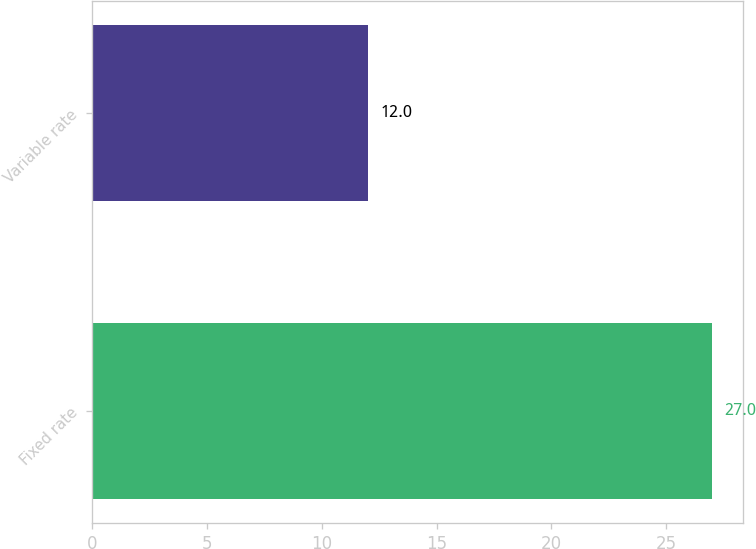<chart> <loc_0><loc_0><loc_500><loc_500><bar_chart><fcel>Fixed rate<fcel>Variable rate<nl><fcel>27<fcel>12<nl></chart> 